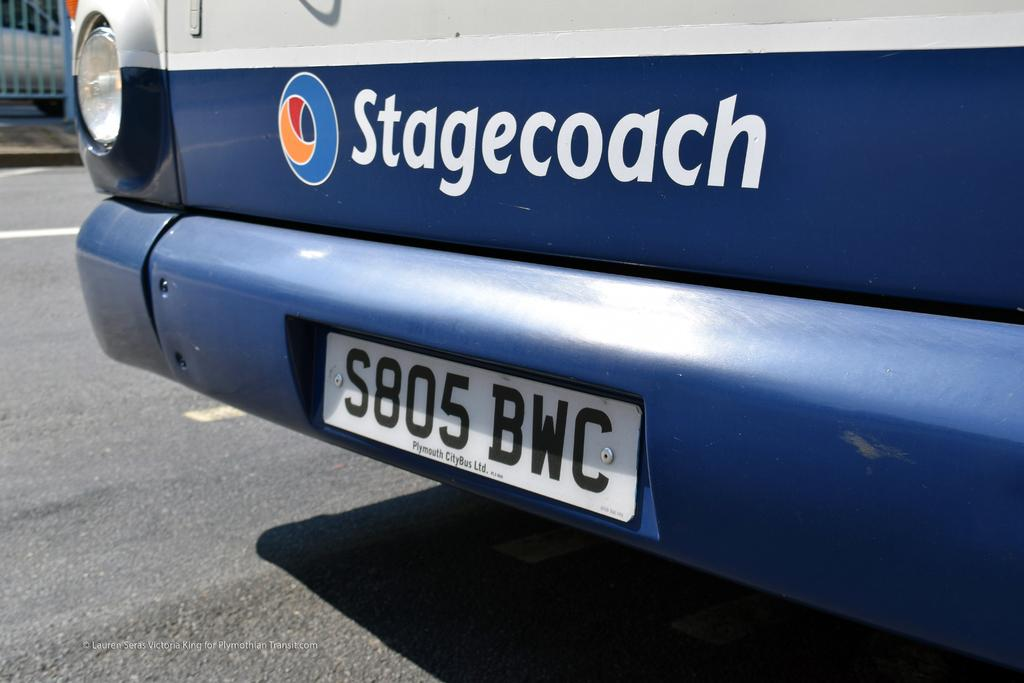<image>
Write a terse but informative summary of the picture. Stagecoach wrote on the front of a type of vehicle 